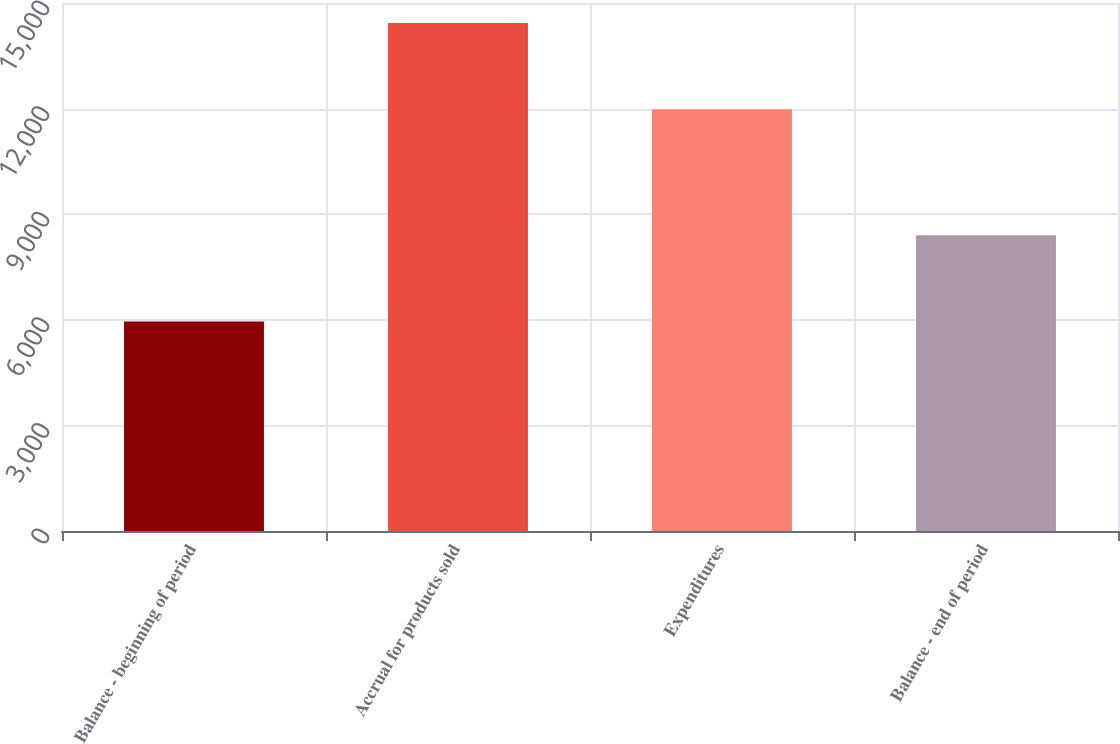Convert chart to OTSL. <chart><loc_0><loc_0><loc_500><loc_500><bar_chart><fcel>Balance - beginning of period<fcel>Accrual for products sold<fcel>Expenditures<fcel>Balance - end of period<nl><fcel>5949<fcel>14429<fcel>11979<fcel>8399<nl></chart> 